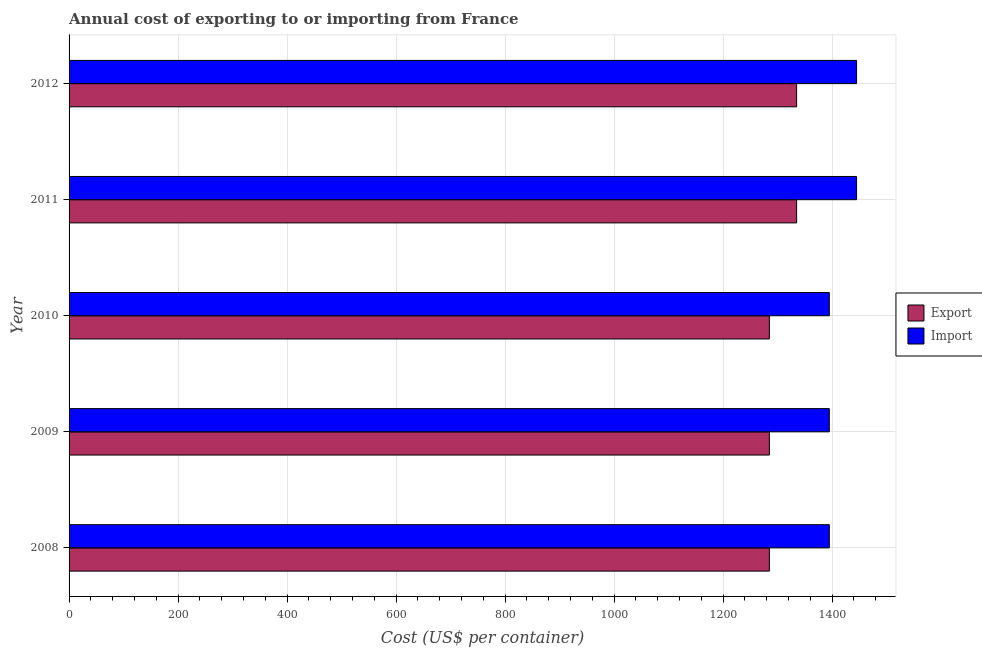How many different coloured bars are there?
Give a very brief answer. 2. Are the number of bars on each tick of the Y-axis equal?
Your answer should be very brief. Yes. In how many cases, is the number of bars for a given year not equal to the number of legend labels?
Offer a terse response. 0. What is the import cost in 2008?
Provide a short and direct response. 1395. Across all years, what is the maximum export cost?
Offer a very short reply. 1335. Across all years, what is the minimum export cost?
Make the answer very short. 1285. In which year was the import cost maximum?
Your response must be concise. 2011. In which year was the import cost minimum?
Your answer should be very brief. 2008. What is the total export cost in the graph?
Your answer should be very brief. 6525. What is the difference between the export cost in 2012 and the import cost in 2010?
Your answer should be very brief. -60. What is the average import cost per year?
Provide a short and direct response. 1415. In the year 2009, what is the difference between the import cost and export cost?
Make the answer very short. 110. What is the ratio of the import cost in 2008 to that in 2012?
Keep it short and to the point. 0.96. Is the export cost in 2010 less than that in 2011?
Provide a succinct answer. Yes. Is the difference between the import cost in 2008 and 2009 greater than the difference between the export cost in 2008 and 2009?
Give a very brief answer. No. What is the difference between the highest and the second highest export cost?
Your answer should be compact. 0. What is the difference between the highest and the lowest import cost?
Provide a short and direct response. 50. In how many years, is the export cost greater than the average export cost taken over all years?
Provide a short and direct response. 2. What does the 1st bar from the top in 2012 represents?
Make the answer very short. Import. What does the 2nd bar from the bottom in 2009 represents?
Make the answer very short. Import. How many years are there in the graph?
Your answer should be compact. 5. Does the graph contain any zero values?
Your response must be concise. No. Where does the legend appear in the graph?
Your response must be concise. Center right. How many legend labels are there?
Provide a short and direct response. 2. What is the title of the graph?
Offer a terse response. Annual cost of exporting to or importing from France. Does "Investment" appear as one of the legend labels in the graph?
Keep it short and to the point. No. What is the label or title of the X-axis?
Your answer should be compact. Cost (US$ per container). What is the label or title of the Y-axis?
Your answer should be very brief. Year. What is the Cost (US$ per container) of Export in 2008?
Provide a succinct answer. 1285. What is the Cost (US$ per container) of Import in 2008?
Make the answer very short. 1395. What is the Cost (US$ per container) of Export in 2009?
Your answer should be compact. 1285. What is the Cost (US$ per container) of Import in 2009?
Keep it short and to the point. 1395. What is the Cost (US$ per container) in Export in 2010?
Give a very brief answer. 1285. What is the Cost (US$ per container) of Import in 2010?
Offer a terse response. 1395. What is the Cost (US$ per container) of Export in 2011?
Your answer should be very brief. 1335. What is the Cost (US$ per container) of Import in 2011?
Offer a terse response. 1445. What is the Cost (US$ per container) of Export in 2012?
Your answer should be compact. 1335. What is the Cost (US$ per container) in Import in 2012?
Offer a terse response. 1445. Across all years, what is the maximum Cost (US$ per container) in Export?
Your answer should be compact. 1335. Across all years, what is the maximum Cost (US$ per container) of Import?
Your answer should be compact. 1445. Across all years, what is the minimum Cost (US$ per container) of Export?
Provide a succinct answer. 1285. Across all years, what is the minimum Cost (US$ per container) in Import?
Provide a succinct answer. 1395. What is the total Cost (US$ per container) of Export in the graph?
Offer a very short reply. 6525. What is the total Cost (US$ per container) of Import in the graph?
Keep it short and to the point. 7075. What is the difference between the Cost (US$ per container) in Import in 2008 and that in 2011?
Provide a succinct answer. -50. What is the difference between the Cost (US$ per container) in Import in 2008 and that in 2012?
Keep it short and to the point. -50. What is the difference between the Cost (US$ per container) of Export in 2009 and that in 2011?
Your answer should be compact. -50. What is the difference between the Cost (US$ per container) in Import in 2009 and that in 2012?
Your answer should be very brief. -50. What is the difference between the Cost (US$ per container) of Export in 2010 and that in 2011?
Your answer should be compact. -50. What is the difference between the Cost (US$ per container) of Import in 2010 and that in 2011?
Make the answer very short. -50. What is the difference between the Cost (US$ per container) in Export in 2010 and that in 2012?
Give a very brief answer. -50. What is the difference between the Cost (US$ per container) of Import in 2011 and that in 2012?
Offer a very short reply. 0. What is the difference between the Cost (US$ per container) of Export in 2008 and the Cost (US$ per container) of Import in 2009?
Make the answer very short. -110. What is the difference between the Cost (US$ per container) in Export in 2008 and the Cost (US$ per container) in Import in 2010?
Provide a short and direct response. -110. What is the difference between the Cost (US$ per container) of Export in 2008 and the Cost (US$ per container) of Import in 2011?
Ensure brevity in your answer.  -160. What is the difference between the Cost (US$ per container) of Export in 2008 and the Cost (US$ per container) of Import in 2012?
Your response must be concise. -160. What is the difference between the Cost (US$ per container) of Export in 2009 and the Cost (US$ per container) of Import in 2010?
Provide a short and direct response. -110. What is the difference between the Cost (US$ per container) of Export in 2009 and the Cost (US$ per container) of Import in 2011?
Give a very brief answer. -160. What is the difference between the Cost (US$ per container) of Export in 2009 and the Cost (US$ per container) of Import in 2012?
Provide a short and direct response. -160. What is the difference between the Cost (US$ per container) in Export in 2010 and the Cost (US$ per container) in Import in 2011?
Provide a succinct answer. -160. What is the difference between the Cost (US$ per container) of Export in 2010 and the Cost (US$ per container) of Import in 2012?
Your answer should be very brief. -160. What is the difference between the Cost (US$ per container) of Export in 2011 and the Cost (US$ per container) of Import in 2012?
Give a very brief answer. -110. What is the average Cost (US$ per container) of Export per year?
Give a very brief answer. 1305. What is the average Cost (US$ per container) in Import per year?
Offer a very short reply. 1415. In the year 2008, what is the difference between the Cost (US$ per container) of Export and Cost (US$ per container) of Import?
Ensure brevity in your answer.  -110. In the year 2009, what is the difference between the Cost (US$ per container) of Export and Cost (US$ per container) of Import?
Ensure brevity in your answer.  -110. In the year 2010, what is the difference between the Cost (US$ per container) of Export and Cost (US$ per container) of Import?
Keep it short and to the point. -110. In the year 2011, what is the difference between the Cost (US$ per container) of Export and Cost (US$ per container) of Import?
Provide a short and direct response. -110. In the year 2012, what is the difference between the Cost (US$ per container) in Export and Cost (US$ per container) in Import?
Your response must be concise. -110. What is the ratio of the Cost (US$ per container) in Import in 2008 to that in 2009?
Offer a terse response. 1. What is the ratio of the Cost (US$ per container) of Export in 2008 to that in 2011?
Make the answer very short. 0.96. What is the ratio of the Cost (US$ per container) of Import in 2008 to that in 2011?
Ensure brevity in your answer.  0.97. What is the ratio of the Cost (US$ per container) of Export in 2008 to that in 2012?
Keep it short and to the point. 0.96. What is the ratio of the Cost (US$ per container) in Import in 2008 to that in 2012?
Your answer should be very brief. 0.97. What is the ratio of the Cost (US$ per container) in Export in 2009 to that in 2010?
Ensure brevity in your answer.  1. What is the ratio of the Cost (US$ per container) of Export in 2009 to that in 2011?
Your response must be concise. 0.96. What is the ratio of the Cost (US$ per container) of Import in 2009 to that in 2011?
Make the answer very short. 0.97. What is the ratio of the Cost (US$ per container) of Export in 2009 to that in 2012?
Your answer should be very brief. 0.96. What is the ratio of the Cost (US$ per container) of Import in 2009 to that in 2012?
Your response must be concise. 0.97. What is the ratio of the Cost (US$ per container) in Export in 2010 to that in 2011?
Make the answer very short. 0.96. What is the ratio of the Cost (US$ per container) of Import in 2010 to that in 2011?
Your response must be concise. 0.97. What is the ratio of the Cost (US$ per container) of Export in 2010 to that in 2012?
Keep it short and to the point. 0.96. What is the ratio of the Cost (US$ per container) of Import in 2010 to that in 2012?
Make the answer very short. 0.97. What is the ratio of the Cost (US$ per container) of Import in 2011 to that in 2012?
Offer a very short reply. 1. What is the difference between the highest and the second highest Cost (US$ per container) in Export?
Your answer should be very brief. 0. What is the difference between the highest and the lowest Cost (US$ per container) in Import?
Make the answer very short. 50. 